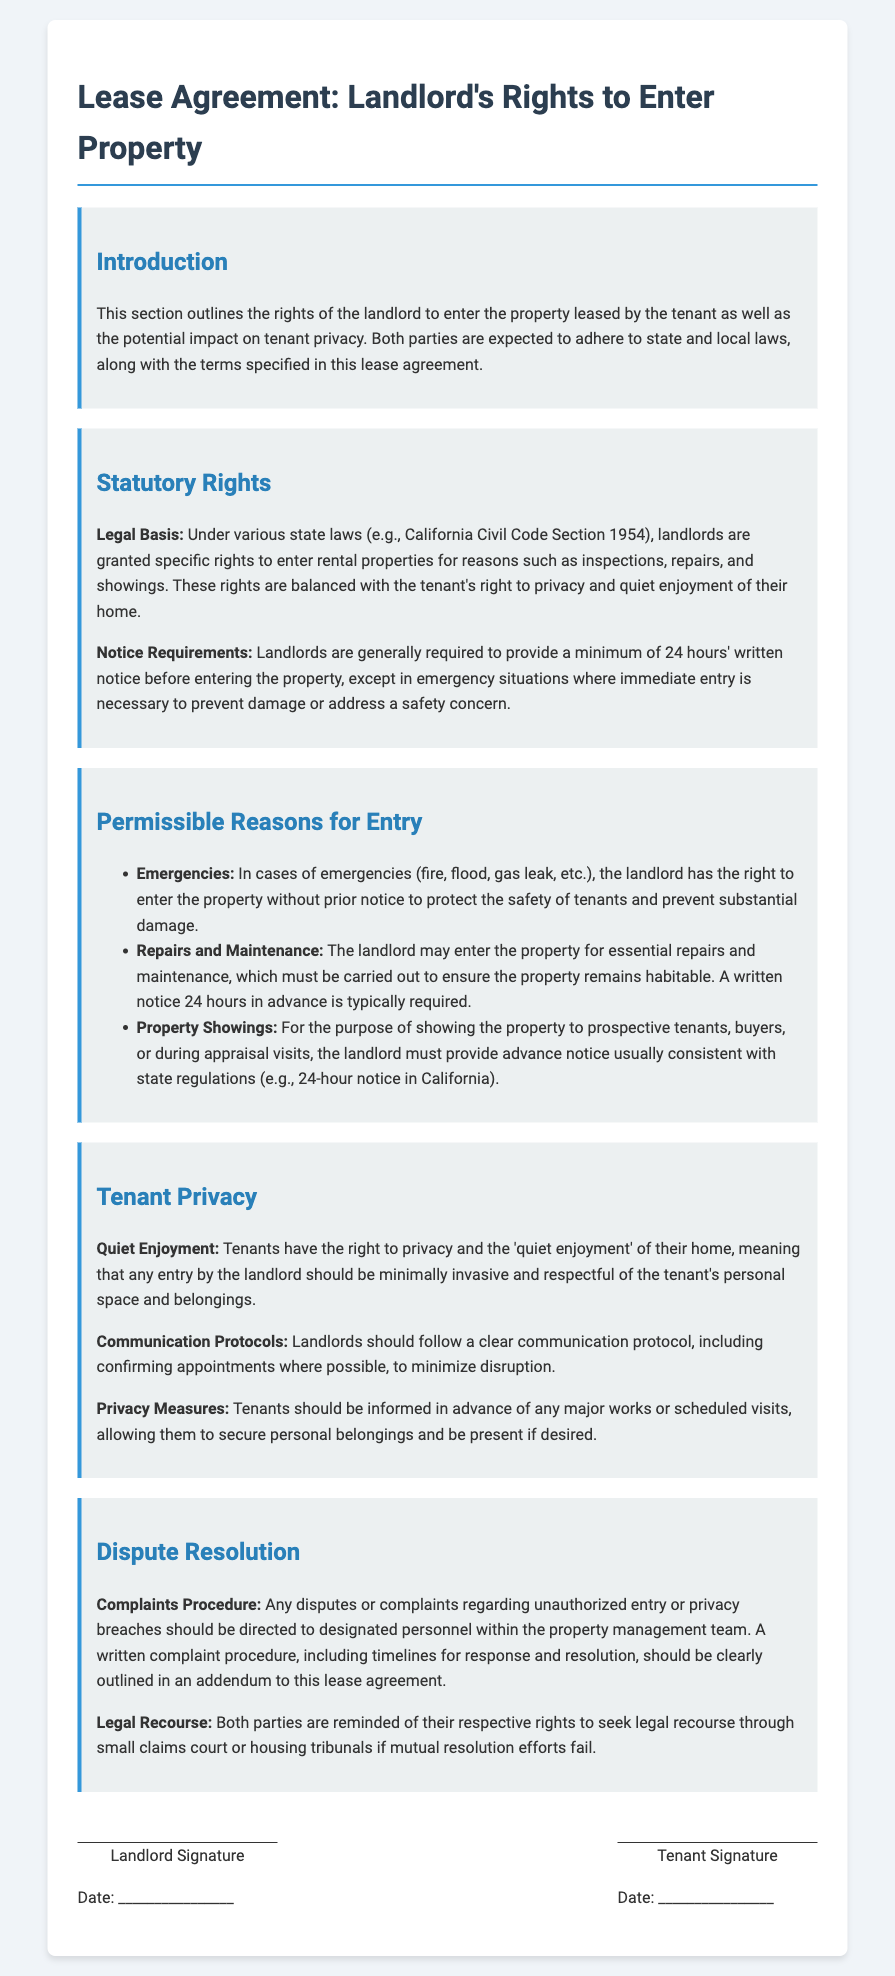What is the legal basis for landlord's rights? The legal basis for landlord's rights is referred to in various state laws, including California Civil Code Section 1954.
Answer: California Civil Code Section 1954 How much notice is required before a landlord can enter a property? Landlords are generally required to provide a minimum of 24 hours' written notice before entering the property.
Answer: 24 hours What are emergencies that allow immediate landlord entry? Emergencies such as fire, flood, gas leak, etc. allow immediate landlord entry without prior notice.
Answer: Fire, flood, gas leak What is the principle of quiet enjoyment? The principle of quiet enjoyment guarantees tenants the right to privacy and a minimally invasive entry by the landlord.
Answer: Privacy and minimal invasion Who should complaints regarding unauthorized entry be directed to? Complaints regarding unauthorized entry should be directed to designated personnel within the property management team.
Answer: Designated personnel What is a tenant's privacy measure before major works? Tenants should be informed in advance of any major works allowing them to secure personal belongings.
Answer: Informed in advance What should landlords follow to minimize disruption for tenants? Landlords should follow a clear communication protocol to minimize disruption during their entries.
Answer: Clear communication protocol What legal recourse do parties have if mutual resolution efforts fail? Both parties can seek legal recourse through small claims court or housing tribunals.
Answer: Small claims court or housing tribunals 